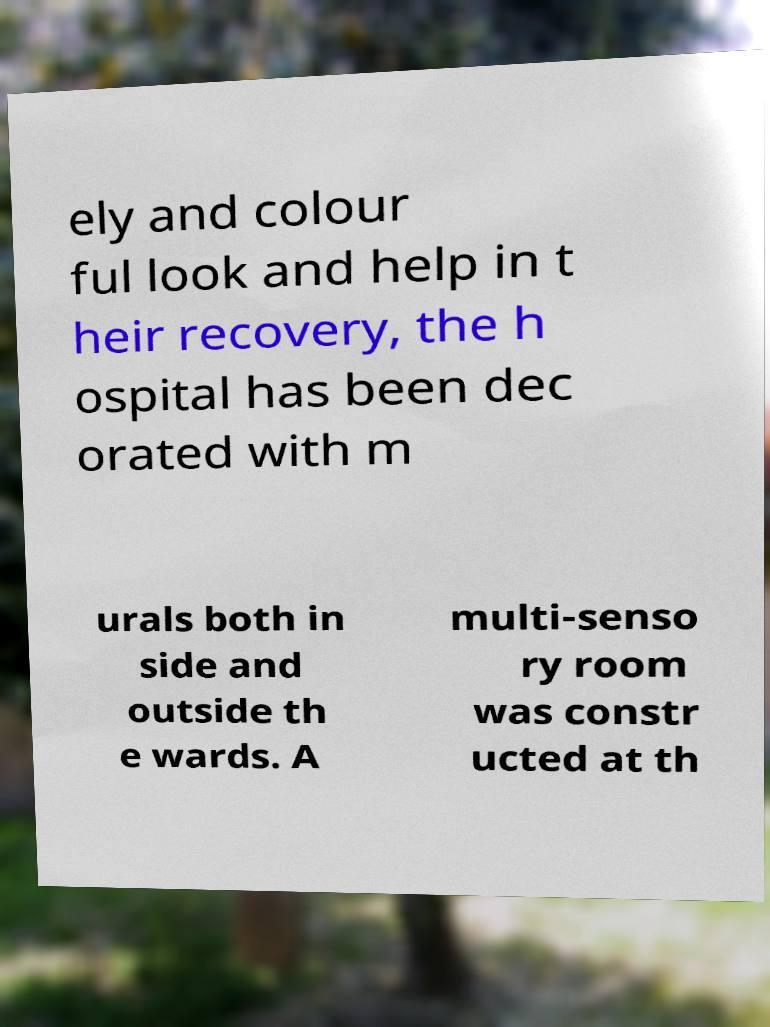Could you extract and type out the text from this image? ely and colour ful look and help in t heir recovery, the h ospital has been dec orated with m urals both in side and outside th e wards. A multi-senso ry room was constr ucted at th 